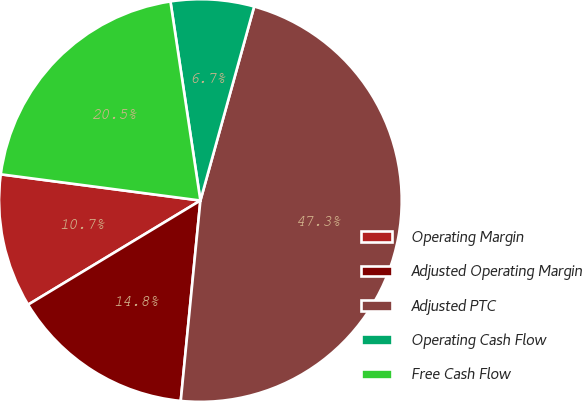Convert chart. <chart><loc_0><loc_0><loc_500><loc_500><pie_chart><fcel>Operating Margin<fcel>Adjusted Operating Margin<fcel>Adjusted PTC<fcel>Operating Cash Flow<fcel>Free Cash Flow<nl><fcel>10.73%<fcel>14.79%<fcel>47.25%<fcel>6.68%<fcel>20.54%<nl></chart> 